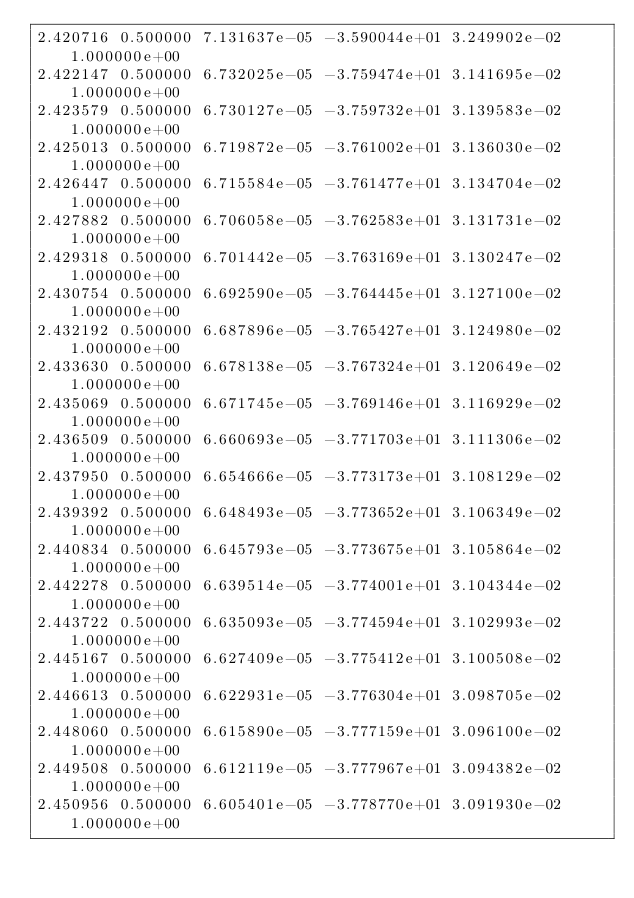Convert code to text. <code><loc_0><loc_0><loc_500><loc_500><_SQL_>2.420716 0.500000 7.131637e-05 -3.590044e+01 3.249902e-02 1.000000e+00 
2.422147 0.500000 6.732025e-05 -3.759474e+01 3.141695e-02 1.000000e+00 
2.423579 0.500000 6.730127e-05 -3.759732e+01 3.139583e-02 1.000000e+00 
2.425013 0.500000 6.719872e-05 -3.761002e+01 3.136030e-02 1.000000e+00 
2.426447 0.500000 6.715584e-05 -3.761477e+01 3.134704e-02 1.000000e+00 
2.427882 0.500000 6.706058e-05 -3.762583e+01 3.131731e-02 1.000000e+00 
2.429318 0.500000 6.701442e-05 -3.763169e+01 3.130247e-02 1.000000e+00 
2.430754 0.500000 6.692590e-05 -3.764445e+01 3.127100e-02 1.000000e+00 
2.432192 0.500000 6.687896e-05 -3.765427e+01 3.124980e-02 1.000000e+00 
2.433630 0.500000 6.678138e-05 -3.767324e+01 3.120649e-02 1.000000e+00 
2.435069 0.500000 6.671745e-05 -3.769146e+01 3.116929e-02 1.000000e+00 
2.436509 0.500000 6.660693e-05 -3.771703e+01 3.111306e-02 1.000000e+00 
2.437950 0.500000 6.654666e-05 -3.773173e+01 3.108129e-02 1.000000e+00 
2.439392 0.500000 6.648493e-05 -3.773652e+01 3.106349e-02 1.000000e+00 
2.440834 0.500000 6.645793e-05 -3.773675e+01 3.105864e-02 1.000000e+00 
2.442278 0.500000 6.639514e-05 -3.774001e+01 3.104344e-02 1.000000e+00 
2.443722 0.500000 6.635093e-05 -3.774594e+01 3.102993e-02 1.000000e+00 
2.445167 0.500000 6.627409e-05 -3.775412e+01 3.100508e-02 1.000000e+00 
2.446613 0.500000 6.622931e-05 -3.776304e+01 3.098705e-02 1.000000e+00 
2.448060 0.500000 6.615890e-05 -3.777159e+01 3.096100e-02 1.000000e+00 
2.449508 0.500000 6.612119e-05 -3.777967e+01 3.094382e-02 1.000000e+00 
2.450956 0.500000 6.605401e-05 -3.778770e+01 3.091930e-02 1.000000e+00 </code> 